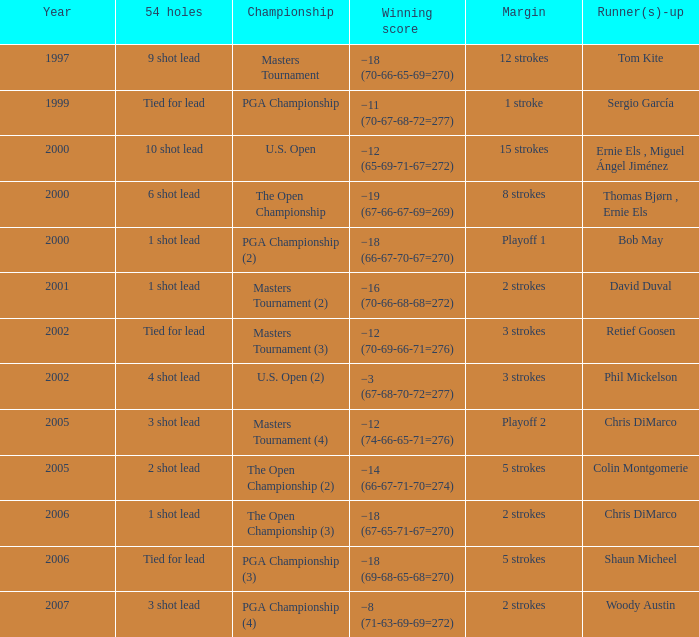 what's the championship where 54 holes is 1 shot lead and runner(s)-up is chris dimarco The Open Championship (3). 